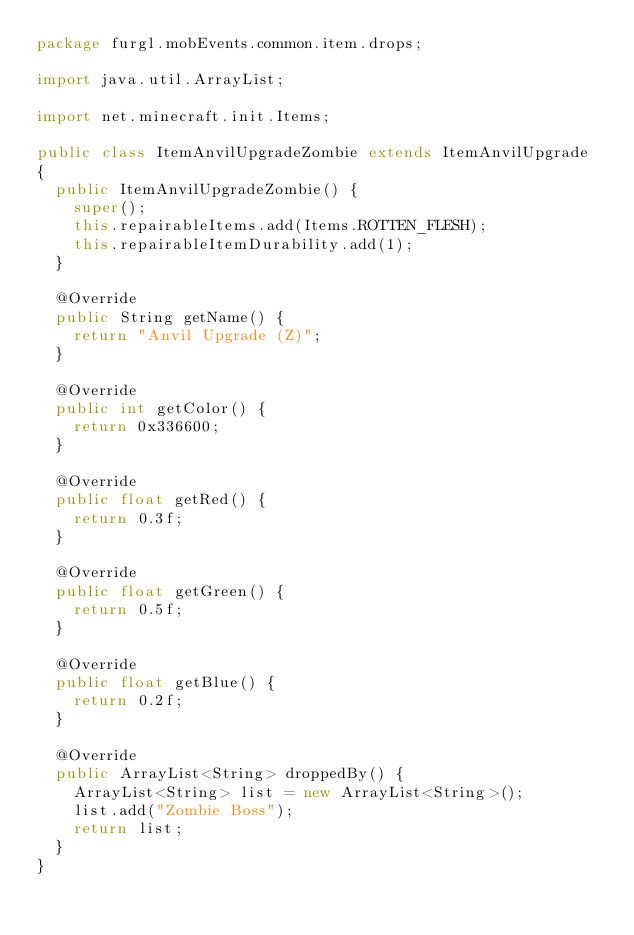Convert code to text. <code><loc_0><loc_0><loc_500><loc_500><_Java_>package furgl.mobEvents.common.item.drops;

import java.util.ArrayList;

import net.minecraft.init.Items;

public class ItemAnvilUpgradeZombie extends ItemAnvilUpgrade
{	
	public ItemAnvilUpgradeZombie() {
		super();
		this.repairableItems.add(Items.ROTTEN_FLESH);
		this.repairableItemDurability.add(1);
	}

	@Override
	public String getName() {
		return "Anvil Upgrade (Z)";
	}

	@Override
	public int getColor() {
		return 0x336600;
	}

	@Override
	public float getRed() {
		return 0.3f;
	}

	@Override
	public float getGreen() {
		return 0.5f;
	}

	@Override
	public float getBlue() {
		return 0.2f;
	}

	@Override
	public ArrayList<String> droppedBy() {
		ArrayList<String> list = new ArrayList<String>();
		list.add("Zombie Boss");
		return list;
	}
}
</code> 